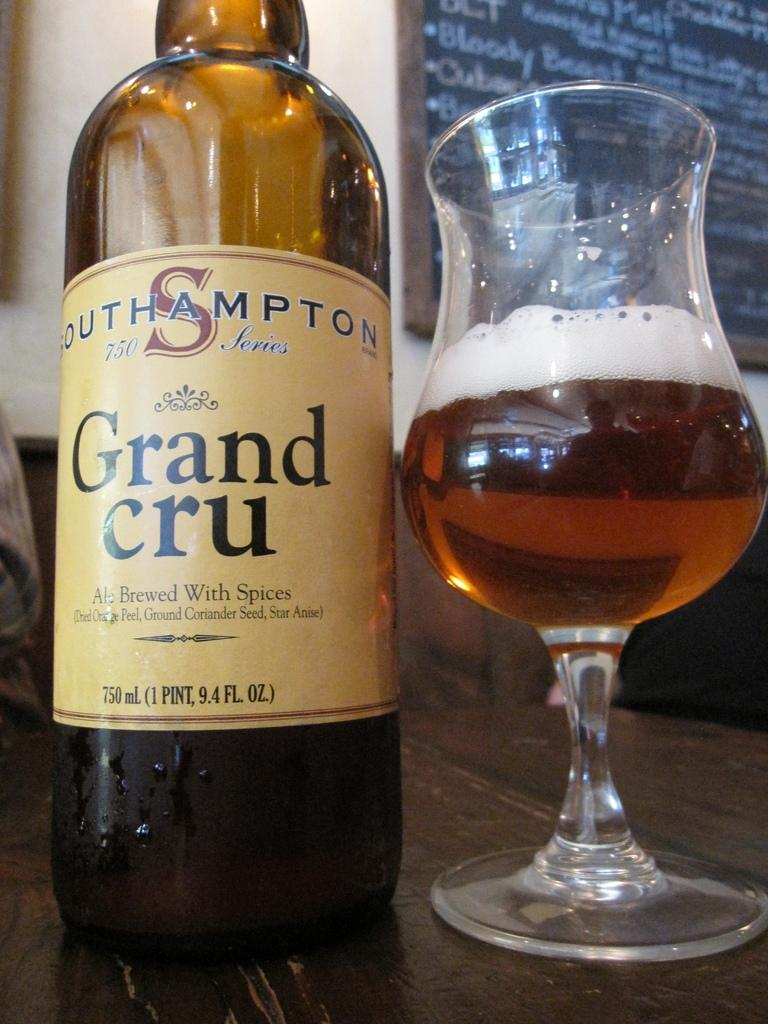<image>
Provide a brief description of the given image. A bottle of Grand Cru sits next to a half-full glass. 